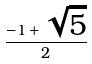<formula> <loc_0><loc_0><loc_500><loc_500>\frac { - 1 + \sqrt { 5 } } { 2 }</formula> 